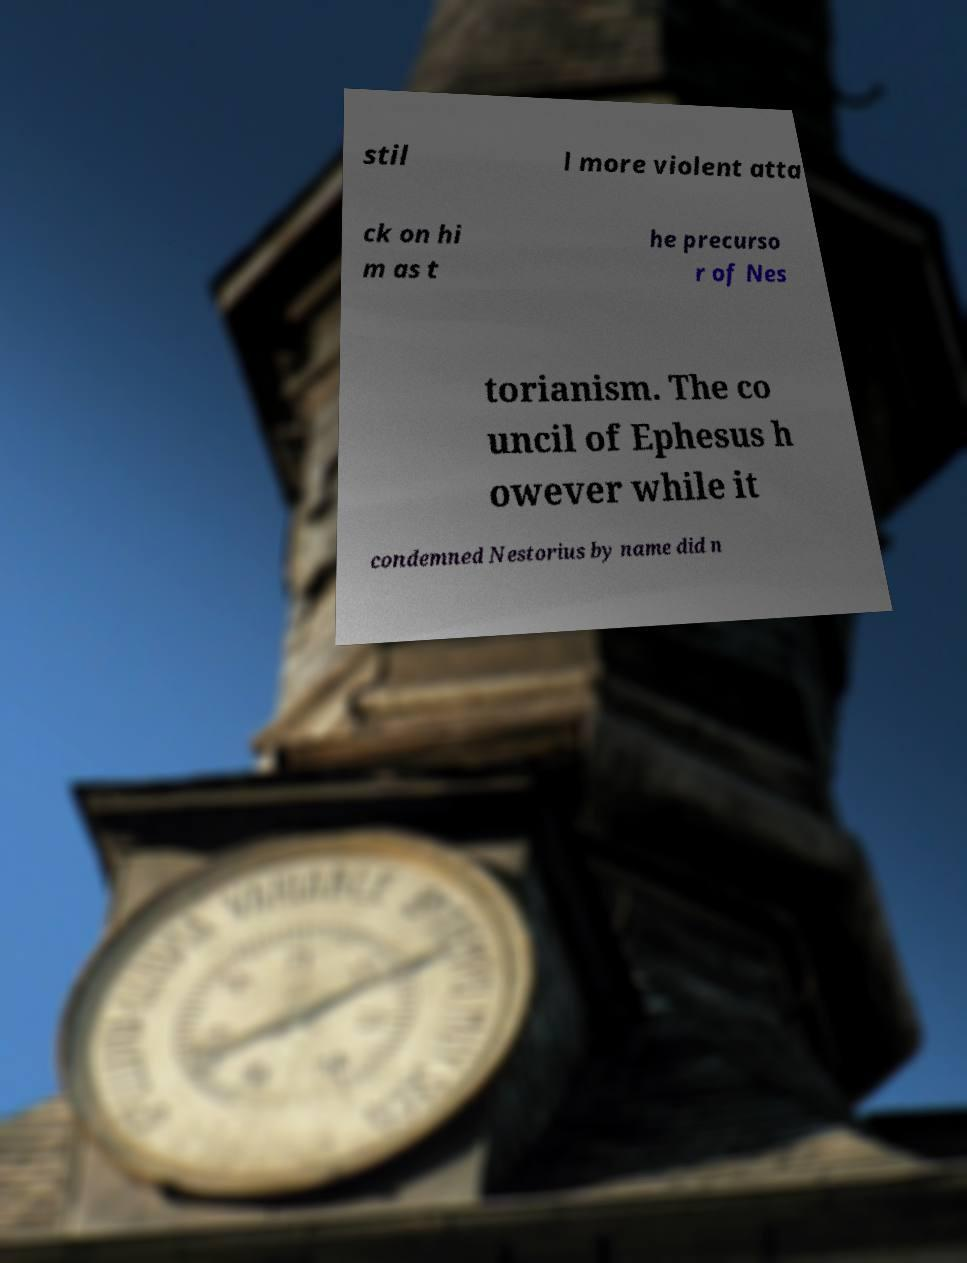What messages or text are displayed in this image? I need them in a readable, typed format. stil l more violent atta ck on hi m as t he precurso r of Nes torianism. The co uncil of Ephesus h owever while it condemned Nestorius by name did n 